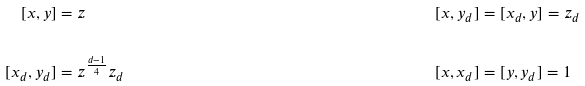Convert formula to latex. <formula><loc_0><loc_0><loc_500><loc_500>[ x , y ] & = z & [ x , y _ { d } ] & = [ x _ { d } , y ] = z _ { d } \\ \\ [ x _ { d } , y _ { d } ] & = z ^ { \frac { d - 1 } { 4 } } z _ { d } & [ x , x _ { d } ] & = [ y , y _ { d } ] = 1</formula> 